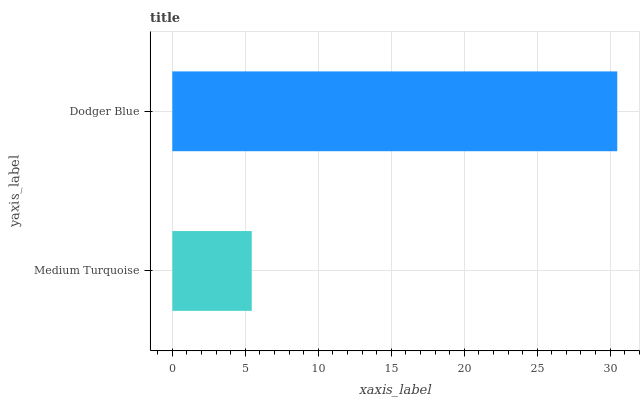Is Medium Turquoise the minimum?
Answer yes or no. Yes. Is Dodger Blue the maximum?
Answer yes or no. Yes. Is Dodger Blue the minimum?
Answer yes or no. No. Is Dodger Blue greater than Medium Turquoise?
Answer yes or no. Yes. Is Medium Turquoise less than Dodger Blue?
Answer yes or no. Yes. Is Medium Turquoise greater than Dodger Blue?
Answer yes or no. No. Is Dodger Blue less than Medium Turquoise?
Answer yes or no. No. Is Dodger Blue the high median?
Answer yes or no. Yes. Is Medium Turquoise the low median?
Answer yes or no. Yes. Is Medium Turquoise the high median?
Answer yes or no. No. Is Dodger Blue the low median?
Answer yes or no. No. 